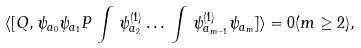<formula> <loc_0><loc_0><loc_500><loc_500>\langle [ Q , \psi _ { a _ { 0 } } \psi _ { a _ { 1 } } P \, \int \, \psi _ { a _ { 2 } } ^ { ( 1 ) } \dots \, \int \, \psi _ { a _ { m - 1 } } ^ { ( 1 ) } \psi _ { a _ { m } } ] \rangle = 0 ( m \geq 2 ) ,</formula> 